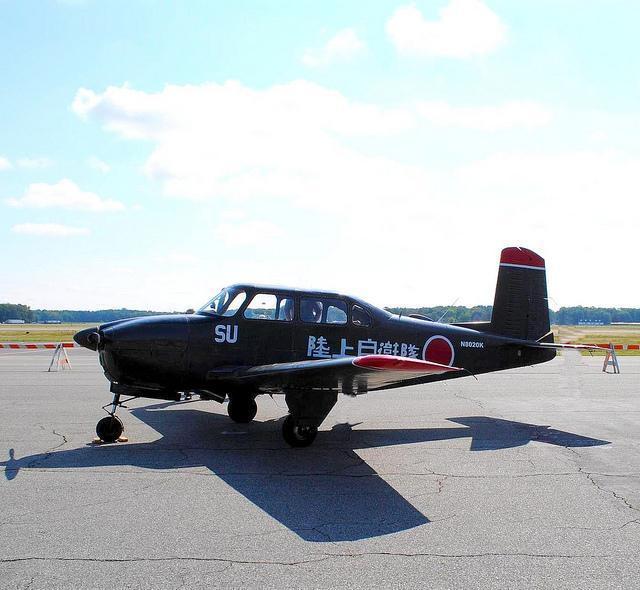How many wheels does the plane have?
Give a very brief answer. 3. How many people are wearing red hats?
Give a very brief answer. 0. 